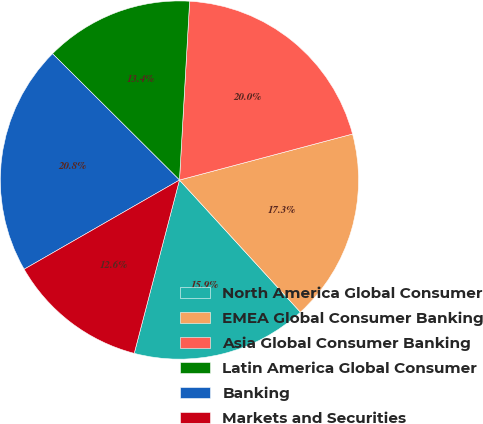Convert chart to OTSL. <chart><loc_0><loc_0><loc_500><loc_500><pie_chart><fcel>North America Global Consumer<fcel>EMEA Global Consumer Banking<fcel>Asia Global Consumer Banking<fcel>Latin America Global Consumer<fcel>Banking<fcel>Markets and Securities<nl><fcel>15.86%<fcel>17.34%<fcel>19.96%<fcel>13.44%<fcel>20.76%<fcel>12.64%<nl></chart> 